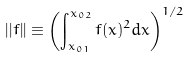<formula> <loc_0><loc_0><loc_500><loc_500>| | f | | \equiv \left ( \int _ { x _ { 0 1 } } ^ { x _ { 0 2 } } f ( x ) ^ { 2 } d x \right ) ^ { 1 / 2 }</formula> 